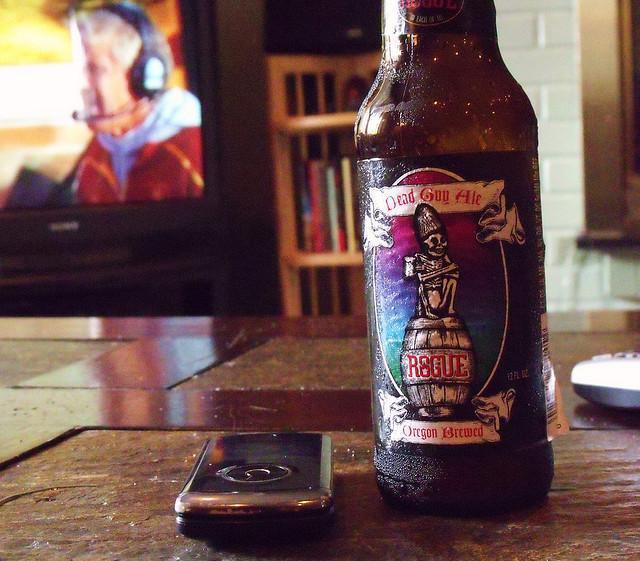Is "The person is touching the dining table." an appropriate description for the image?
Answer yes or no. No. 